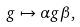Convert formula to latex. <formula><loc_0><loc_0><loc_500><loc_500>g \mapsto \alpha g \beta ,</formula> 